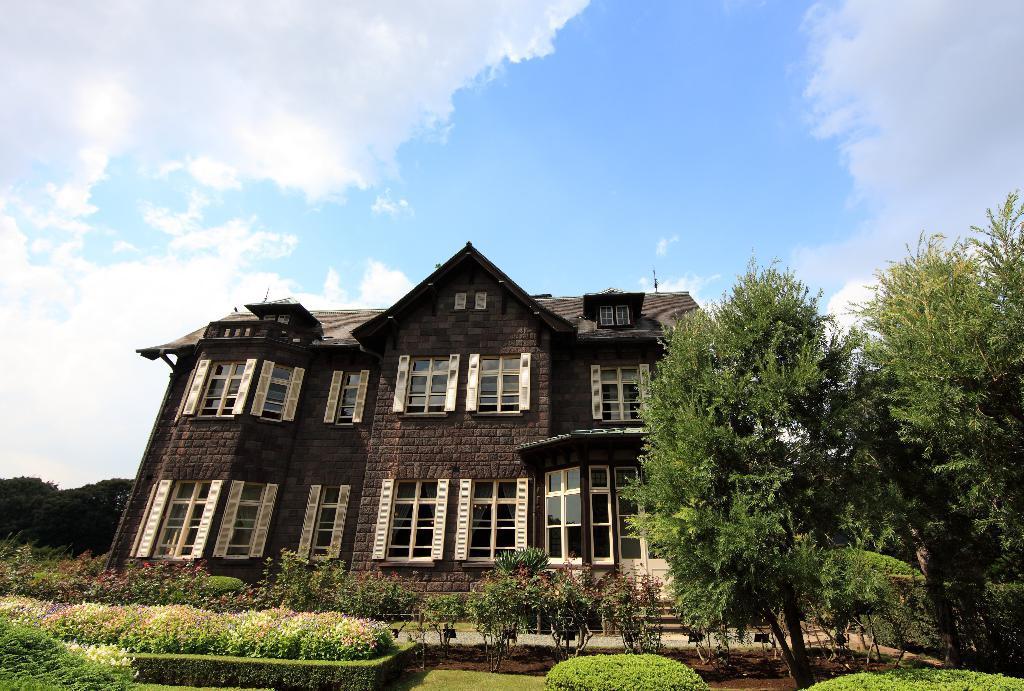How would you summarize this image in a sentence or two? In this image we can see a house, there are some plants, trees around the house, there are some windows, also we can see the sky. 